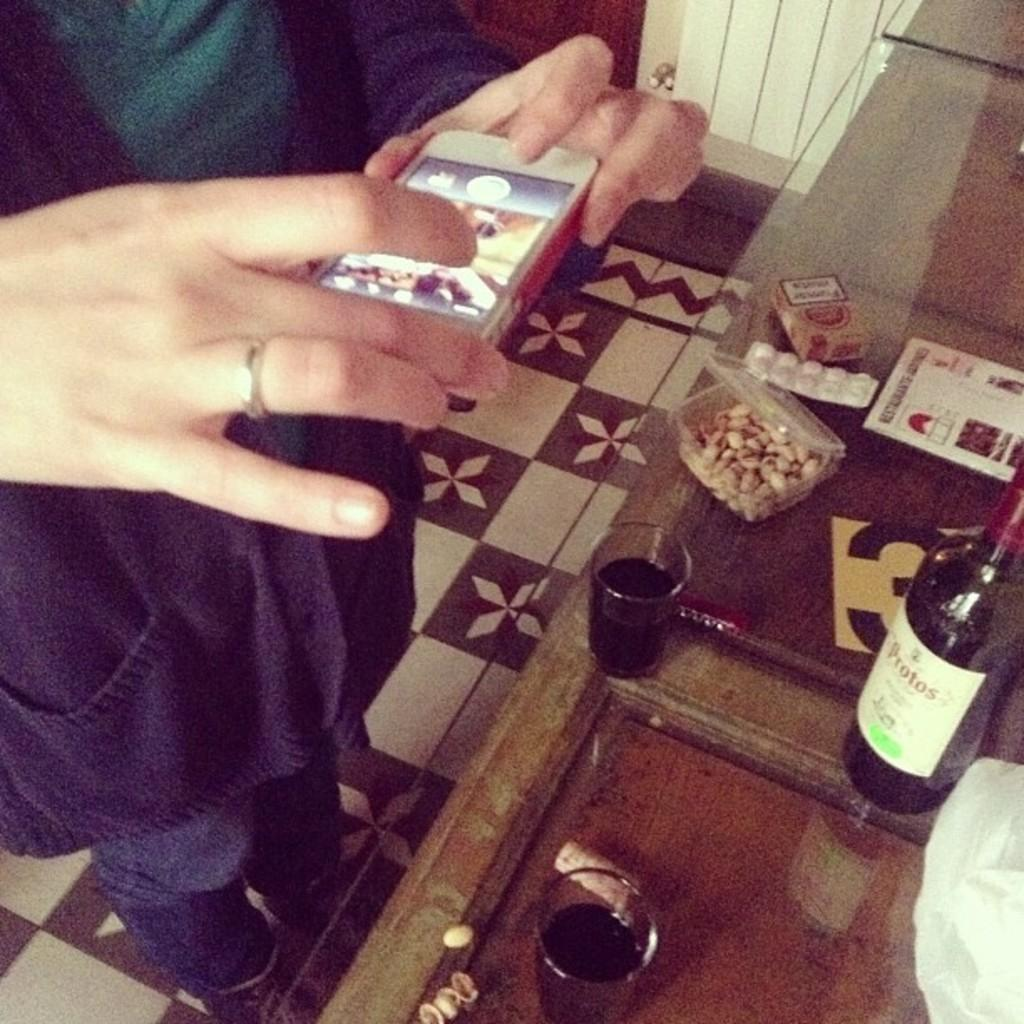What is the person in the image doing? The person is taking a snap with a camera. What objects can be seen on the table in the image? There are glasses, a bottle, and a box on the table. What part of the room is visible in the image? The floor is visible in the image. What type of mask is the person wearing in the image? There is no mask present in the image; the person is taking a snap with a camera. Can you see any branches in the image? There are no branches visible in the image. 